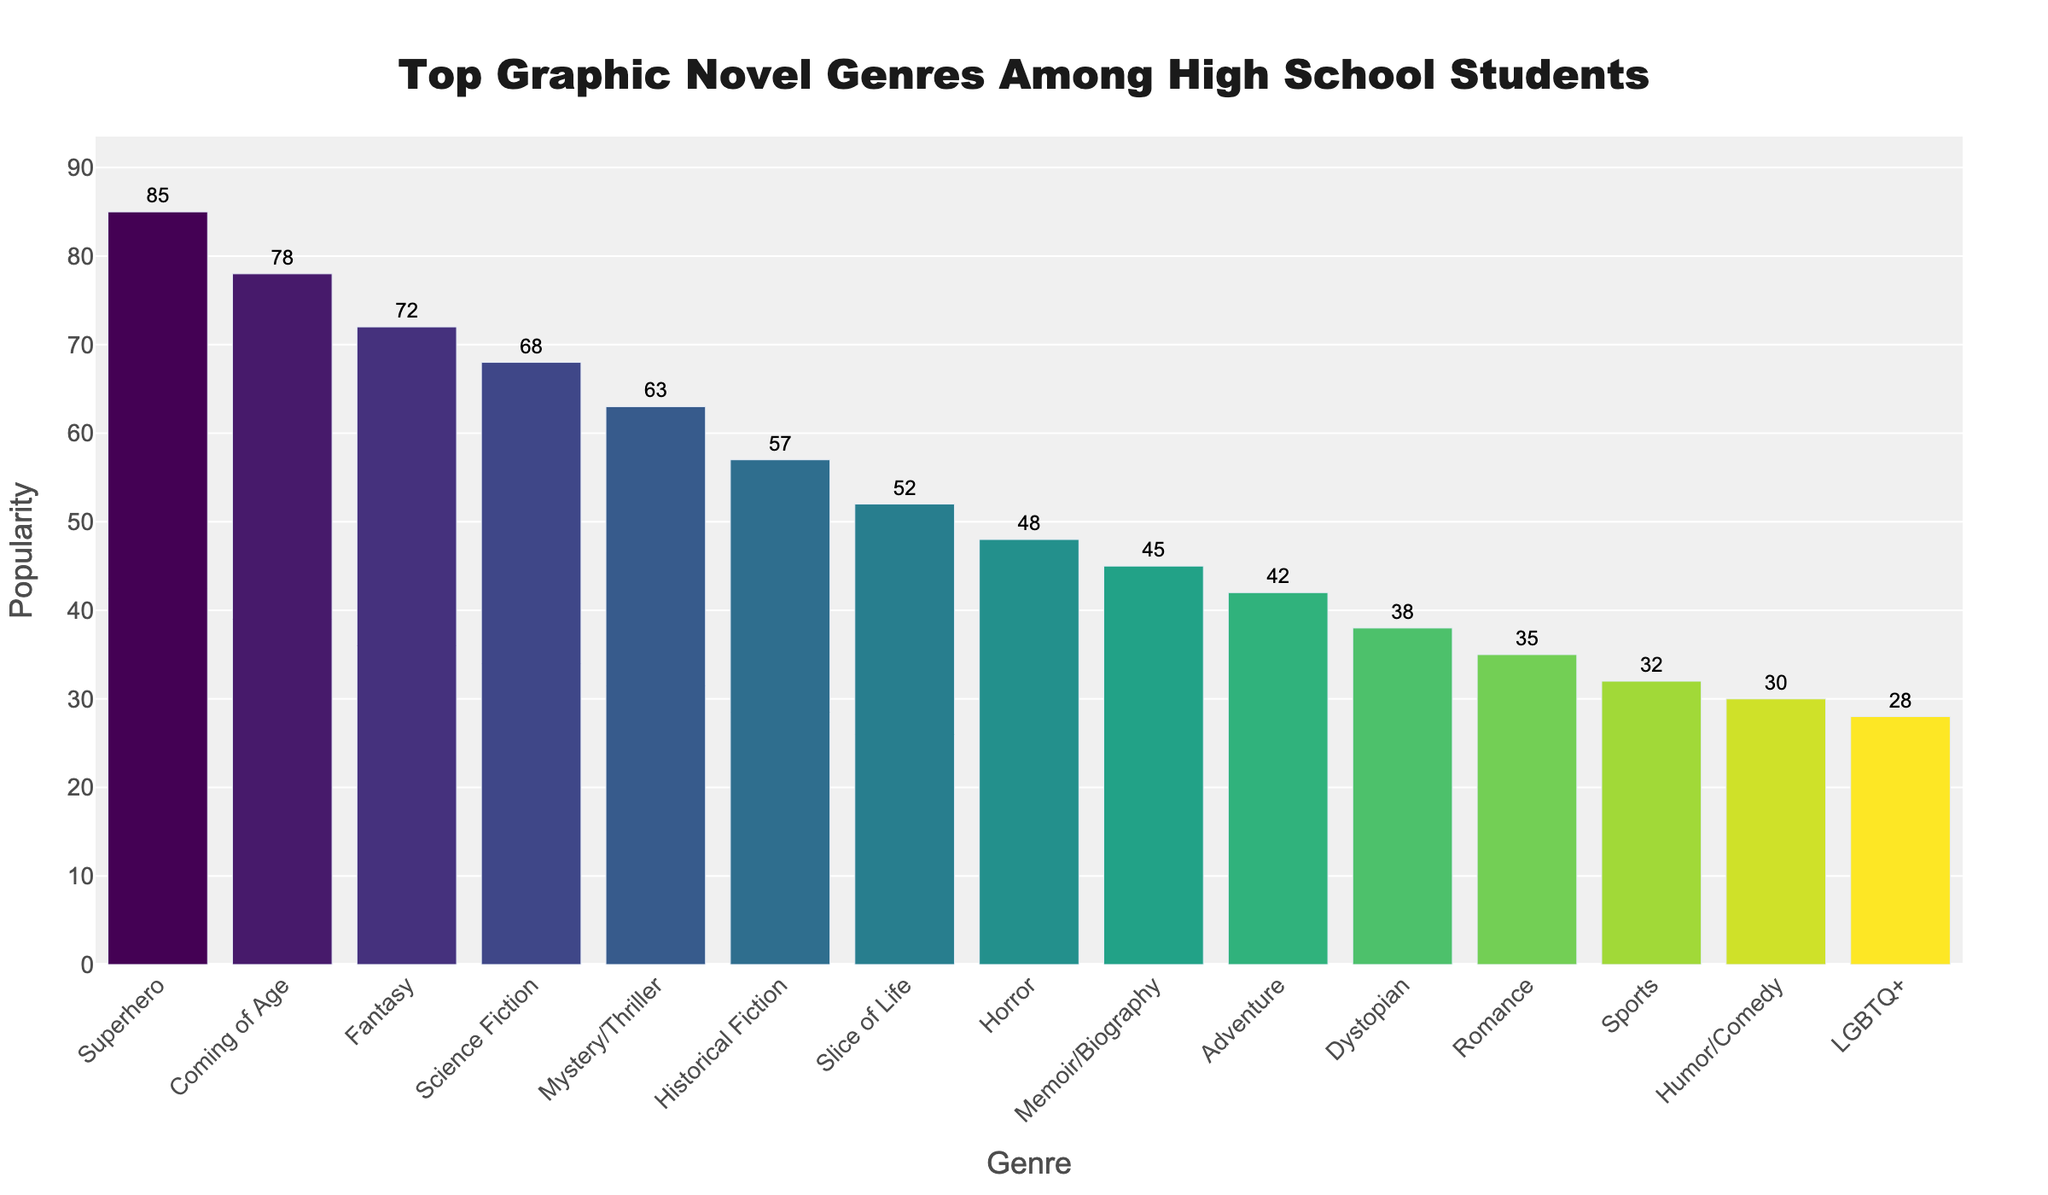Which genre is the most popular among high school students? The tallest bar in the chart represents the most popular genre. The bar for "Superhero" is the tallest.
Answer: Superhero What is the difference in popularity between "Superhero" and "Fantasy"? The "Superhero" genre has a popularity of 85, and the "Fantasy" genre has a popularity of 72. Subtract 72 from 85.
Answer: 13 How does the popularity of "Science Fiction" compare to "Horror"? The popularity of "Science Fiction" is 68, whereas the popularity of "Horror" is 48. Compare 68 and 48.
Answer: Science Fiction is more popular What is the combined popularity of "Coming of Age" and "Mystery/Thriller"? The popularity of "Coming of Age" is 78 and "Mystery/Thriller" is 63. Add these together: 78 + 63.
Answer: 141 Which genres have a popularity score higher than 50? Look for bars whose heights go above the 50 mark. These genres are: "Superhero", "Coming of Age", "Fantasy", "Science Fiction", "Mystery/Thriller", and "Historical Fiction". List them.
Answer: Superhero, Coming of Age, Fantasy, Science Fiction, Mystery/Thriller, Historical Fiction What is the median popularity value among the top 10 most popular genres? List the popularity values of the top 10 genres: 85, 78, 72, 68, 63, 57, 52, 48, 45, and 42. To find the median, place them in ascending order: 42, 45, 48, 52, 57, 63, 68, 72, 78, 85. The median is the average of the 5th and 6th values. Find the average of 57 and 63: (57 + 63)/2.
Answer: 60 What genre is represented by the bar with the fourth highest height? The fourth highest value in descending order is 68, which corresponds to "Science Fiction".
Answer: Science Fiction How does the popularity of "Romance" compare to "Sports"? The popularity of "Romance" is 35 and "Sports" is 32. Compare 35 and 32.
Answer: Romance is more popular Which genre has the lowest popularity score and what is it? The shortest bar represents the genre with the lowest popularity. The shortest bar is "LGBTQ+" with a popularity score of 28.
Answer: LGBTQ+, 28 What is the average popularity score of the top three genres? The top three genres are "Superhero", "Coming of Age", and "Fantasy" with scores 85, 78, and 72 respectively. Add these scores: 85 + 78 + 72 = 235. Then divide by 3: 235/3.
Answer: 78.33 